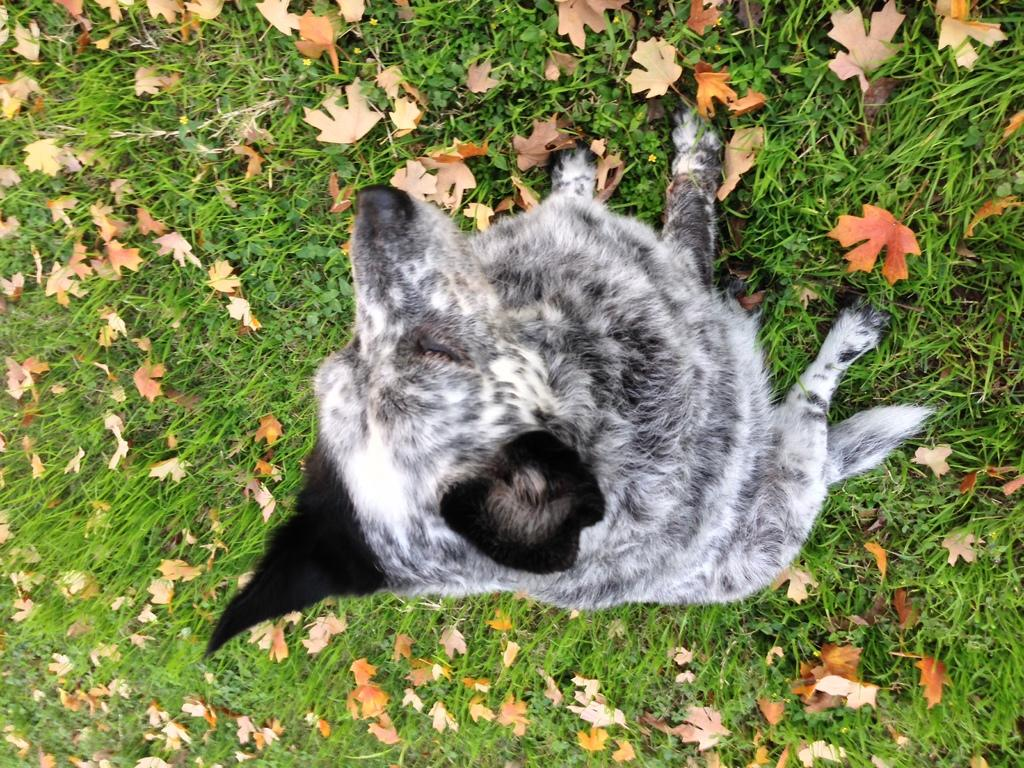What animal is sitting in the image? There is a dog sitting in the image. What type of vegetation is present in the image? Dried leaves are lying on the grass in the image. What type of whip can be seen in the image? There is no whip present in the image. What type of linen is visible in the image? There is no linen present in the image. 